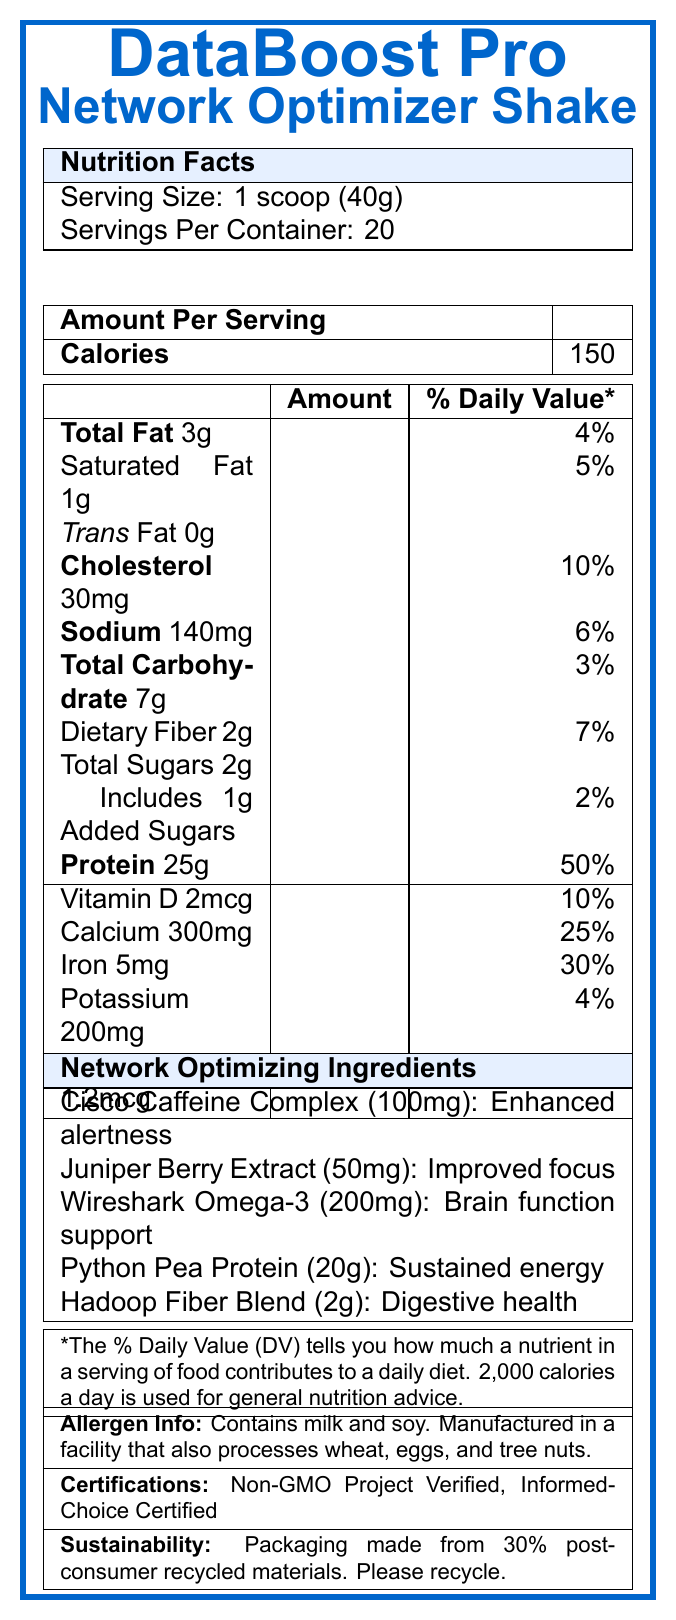what is the serving size of DataBoost Pro? The serving size is listed as "1 scoop (40g)" in the Nutrition Facts section at the top of the document.
Answer: 1 scoop (40g) how many calories are in one serving of DataBoost Pro? The Calories section lists 150 calories per serving.
Answer: 150 what is the total fat content in one serving? The document shows that 1 serving contains 3g of total fat in the Nutrition Facts section.
Answer: 3g how much cholesterol does one serving contain? The amount of cholesterol per serving is listed as 30mg in the Nutrition Facts.
Answer: 30mg what is the main function of Wireshark Omega-3 in DataBoost Pro? The Network Optimizing Ingredients section states that Wireshark Omega-3 offers "Brain function support for packet analysis".
Answer: Brain function support for packet analysis which of the following vitamins is present in the highest percentage of the daily value? A. Vitamin D B. Calcium C. Iron D. Vitamin B12 The document lists Vitamin B12 at 50% of the daily value, which is the highest among the vitamins listed.
Answer: D. Vitamin B12 which ingredient is responsible for enhanced alertness? 1. Juniper Berry Extract 2. Wireshark Omega-3 3. Cisco Caffeine Complex The Network Optimizing Ingredients section states that Cisco Caffeine Complex provides "Enhanced alertness".
Answer: 3. Cisco Caffeine Complex Is the product suitable for people with a tree nut allergy? The allergen information section indicates that the product is manufactured in a facility that also processes tree nuts.
Answer: No what are the storage instructions for DataBoost Pro? The section titled "storageInstructions" provides these instructions.
Answer: Store in a cool, dry place. Refrigerate after opening. summarize the purpose and key features of DataBoost Pro. The document provides detailed information on the nutrient content, the specific benefits of the included network-optimizing ingredients, storage instructions, allergen information, and sustainability features.
Answer: DataBoost Pro is a high-protein meal replacement shake designed to optimize network performance and support IT professionals. It provides 150 calories, 25g of protein, and various network-optimizing ingredients like Cisco Caffeine Complex and Wireshark Omega-3. It includes all essential nutrients and is Non-GMO Project Verified. The product is convenient, mindful of allergens, and has sustainable packaging. what is the primary benefit of drinking DataBoost Pro for network professionals? The Network Optimizing Ingredients in DataBoost Pro, such as Cisco Caffeine Complex, Juniper Berry Extract, and Wireshark Omega-3, provide benefits like enhanced alertness, improved focus, and brain function support, which are particularly useful for network professionals.
Answer: Enhanced alertness, improved focus, and brain function support what certifications does DataBoost Pro hold? These certifications are listed in the document under the "certifications" section.
Answer: Non-GMO Project Verified, Informed-Choice Certified how many servings are there in one container of DataBoost Pro? The servings per container are listed as 20 in the Nutrition Facts section.
Answer: 20 what is the percentage of daily value for sodium in one serving? The document states that one serving contains 140mg of sodium, which is 6% of the daily value.
Answer: 6% what has the highest amount in milligrams among the listed network optimizing ingredients? Wireshark Omega-3 is listed as having 200mg, which is higher than the amounts for the other listed network-optimizing ingredients.
Answer: Wireshark Omega-3 which ingredient offers sustained energy for coding sessions? 1. Cisco Caffeine Complex 2. Python Pea Protein 3. Hadoop Fiber Blend The Network Optimizing Ingredients section mentions that Python Pea Protein provides "Sustained energy for coding sessions".
Answer: 2. Python Pea Protein what is the carbohydrate content (in grams) per serving? The total carbohydrate content per serving is listed as 7g in the Nutrition Facts section.
Answer: 7g how many grams of dietary fiber are in one serving? The Nutrition Facts section lists 2g of dietary fiber per serving.
Answer: 2g is this product evaluated by the Food and Drug Administration? The disclaimer mentions that the statements have not been evaluated by the Food and Drug Administration.
Answer: No what is the physical address of BigData Nutrition, Inc.? This information is provided in the manufacturer section of the document.
Answer: 1234 Analytics Ave, Silicon Valley, CA 94000 what total volume of water or milk should one use to mix one scoop of DataBoost Pro? The directions indicate mixing one scoop with 8-10 oz of cold water or favorite milk.
Answer: 8-10 oz is Python Pea Protein the only ingredient in DataBoost Pro that supports coding sessions? The document does not provide enough information to conclude whether other ingredients might also support coding sessions.
Answer: Cannot be determined 